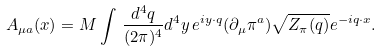Convert formula to latex. <formula><loc_0><loc_0><loc_500><loc_500>A _ { \mu a } ( x ) = M \int \, { \frac { d ^ { 4 } q } { ( 2 \pi ) ^ { 4 } } } d ^ { 4 } y \, e ^ { i y \cdot q } ( \partial _ { \mu } \pi ^ { a } ) \sqrt { Z _ { \pi } ( q ) } e ^ { - i q \cdot x } .</formula> 